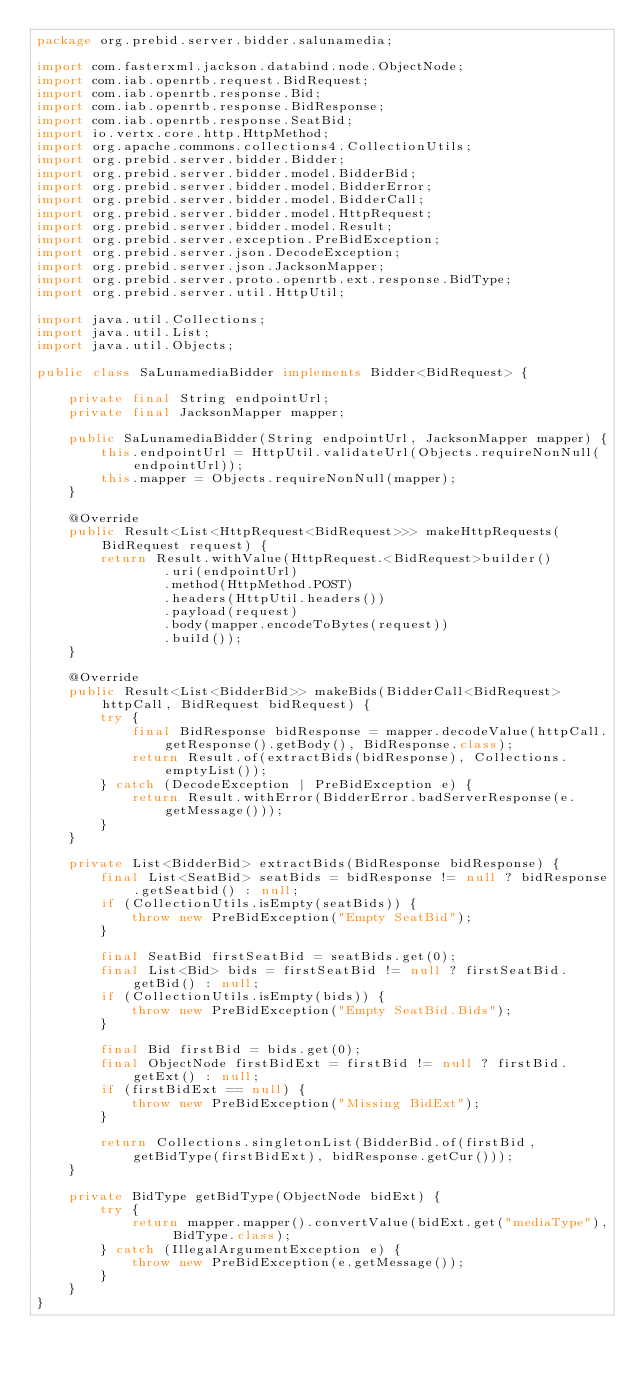<code> <loc_0><loc_0><loc_500><loc_500><_Java_>package org.prebid.server.bidder.salunamedia;

import com.fasterxml.jackson.databind.node.ObjectNode;
import com.iab.openrtb.request.BidRequest;
import com.iab.openrtb.response.Bid;
import com.iab.openrtb.response.BidResponse;
import com.iab.openrtb.response.SeatBid;
import io.vertx.core.http.HttpMethod;
import org.apache.commons.collections4.CollectionUtils;
import org.prebid.server.bidder.Bidder;
import org.prebid.server.bidder.model.BidderBid;
import org.prebid.server.bidder.model.BidderError;
import org.prebid.server.bidder.model.BidderCall;
import org.prebid.server.bidder.model.HttpRequest;
import org.prebid.server.bidder.model.Result;
import org.prebid.server.exception.PreBidException;
import org.prebid.server.json.DecodeException;
import org.prebid.server.json.JacksonMapper;
import org.prebid.server.proto.openrtb.ext.response.BidType;
import org.prebid.server.util.HttpUtil;

import java.util.Collections;
import java.util.List;
import java.util.Objects;

public class SaLunamediaBidder implements Bidder<BidRequest> {

    private final String endpointUrl;
    private final JacksonMapper mapper;

    public SaLunamediaBidder(String endpointUrl, JacksonMapper mapper) {
        this.endpointUrl = HttpUtil.validateUrl(Objects.requireNonNull(endpointUrl));
        this.mapper = Objects.requireNonNull(mapper);
    }

    @Override
    public Result<List<HttpRequest<BidRequest>>> makeHttpRequests(BidRequest request) {
        return Result.withValue(HttpRequest.<BidRequest>builder()
                .uri(endpointUrl)
                .method(HttpMethod.POST)
                .headers(HttpUtil.headers())
                .payload(request)
                .body(mapper.encodeToBytes(request))
                .build());
    }

    @Override
    public Result<List<BidderBid>> makeBids(BidderCall<BidRequest> httpCall, BidRequest bidRequest) {
        try {
            final BidResponse bidResponse = mapper.decodeValue(httpCall.getResponse().getBody(), BidResponse.class);
            return Result.of(extractBids(bidResponse), Collections.emptyList());
        } catch (DecodeException | PreBidException e) {
            return Result.withError(BidderError.badServerResponse(e.getMessage()));
        }
    }

    private List<BidderBid> extractBids(BidResponse bidResponse) {
        final List<SeatBid> seatBids = bidResponse != null ? bidResponse.getSeatbid() : null;
        if (CollectionUtils.isEmpty(seatBids)) {
            throw new PreBidException("Empty SeatBid");
        }

        final SeatBid firstSeatBid = seatBids.get(0);
        final List<Bid> bids = firstSeatBid != null ? firstSeatBid.getBid() : null;
        if (CollectionUtils.isEmpty(bids)) {
            throw new PreBidException("Empty SeatBid.Bids");
        }

        final Bid firstBid = bids.get(0);
        final ObjectNode firstBidExt = firstBid != null ? firstBid.getExt() : null;
        if (firstBidExt == null) {
            throw new PreBidException("Missing BidExt");
        }

        return Collections.singletonList(BidderBid.of(firstBid, getBidType(firstBidExt), bidResponse.getCur()));
    }

    private BidType getBidType(ObjectNode bidExt) {
        try {
            return mapper.mapper().convertValue(bidExt.get("mediaType"), BidType.class);
        } catch (IllegalArgumentException e) {
            throw new PreBidException(e.getMessage());
        }
    }
}
</code> 